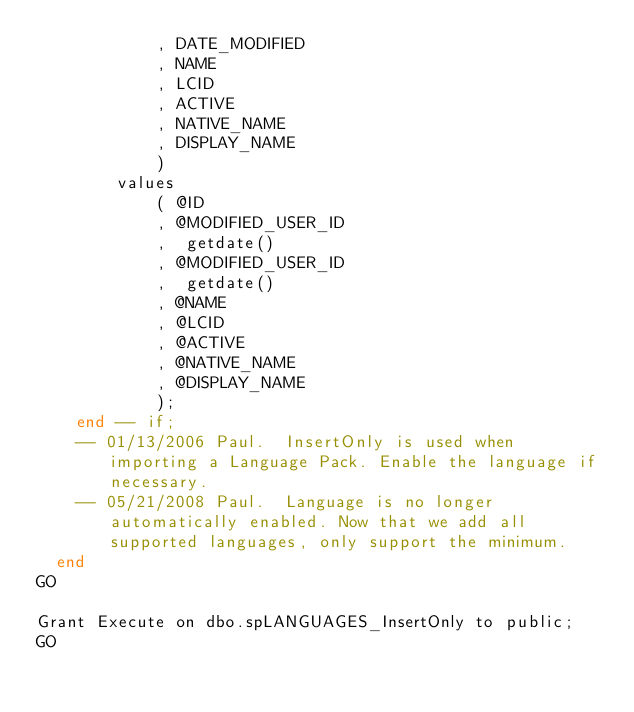<code> <loc_0><loc_0><loc_500><loc_500><_SQL_>			, DATE_MODIFIED    
			, NAME             
			, LCID             
			, ACTIVE           
			, NATIVE_NAME      
			, DISPLAY_NAME     
			)
		values
			( @ID               
			, @MODIFIED_USER_ID 
			,  getdate()        
			, @MODIFIED_USER_ID 
			,  getdate()        
			, @NAME             
			, @LCID             
			, @ACTIVE           
			, @NATIVE_NAME      
			, @DISPLAY_NAME     
			);
	end -- if;
	-- 01/13/2006 Paul.  InsertOnly is used when importing a Language Pack. Enable the language if necessary. 
	-- 05/21/2008 Paul.  Language is no longer automatically enabled. Now that we add all supported languages, only support the minimum. 
  end
GO
 
Grant Execute on dbo.spLANGUAGES_InsertOnly to public;
GO
 
</code> 